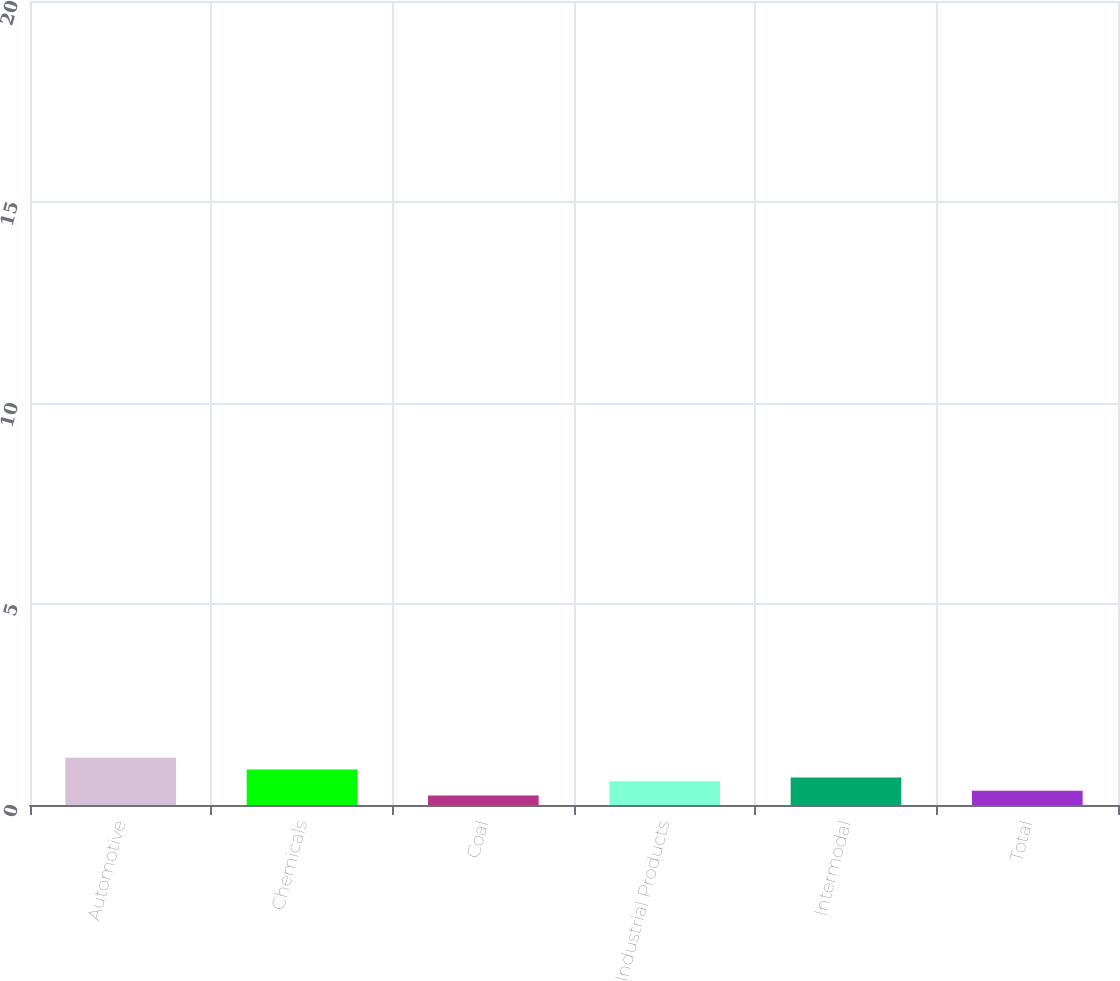Convert chart. <chart><loc_0><loc_0><loc_500><loc_500><bar_chart><fcel>Automotive<fcel>Chemicals<fcel>Coal<fcel>Industrial Products<fcel>Intermodal<fcel>Total<nl><fcel>20<fcel>15<fcel>4<fcel>10<fcel>11.6<fcel>6<nl></chart> 